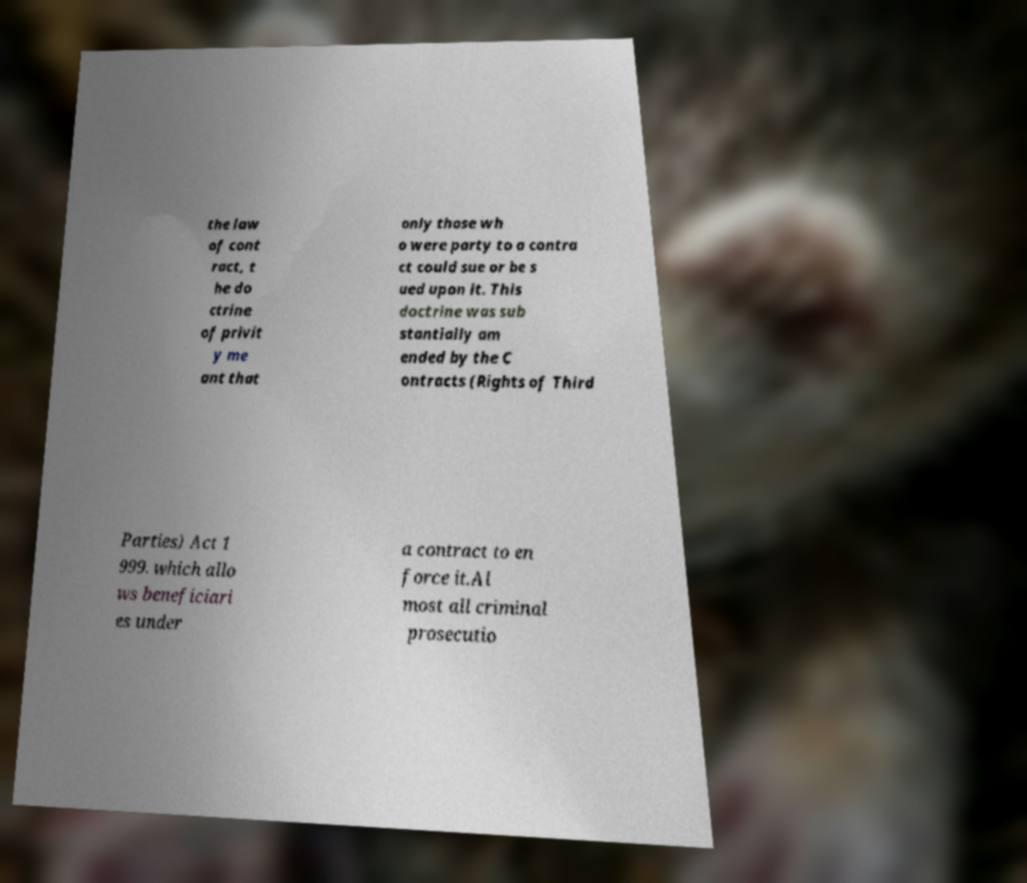Could you extract and type out the text from this image? the law of cont ract, t he do ctrine of privit y me ant that only those wh o were party to a contra ct could sue or be s ued upon it. This doctrine was sub stantially am ended by the C ontracts (Rights of Third Parties) Act 1 999. which allo ws beneficiari es under a contract to en force it.Al most all criminal prosecutio 